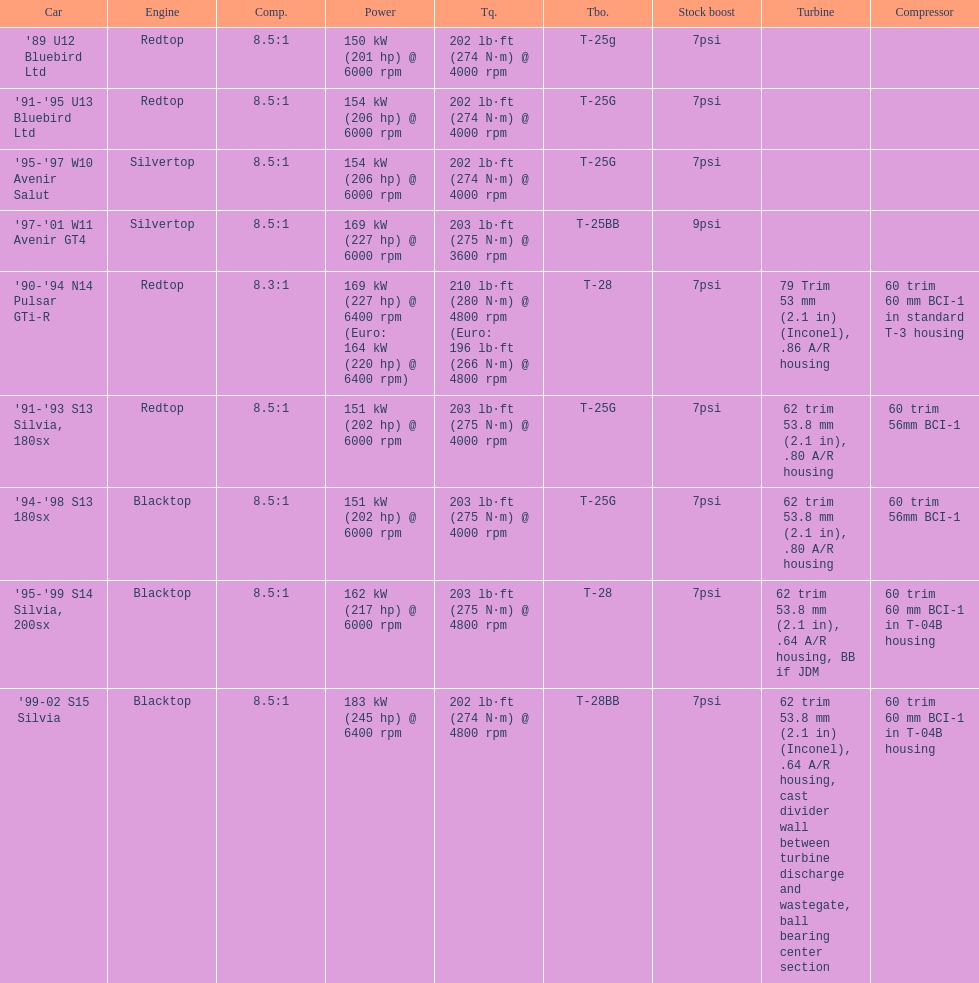Which automobile's strength is assessed above 6000 rpm? '90-'94 N14 Pulsar GTi-R, '99-02 S15 Silvia. 